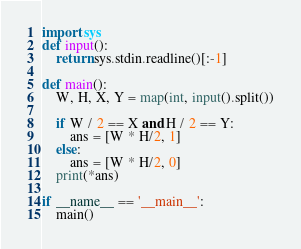Convert code to text. <code><loc_0><loc_0><loc_500><loc_500><_Python_>import sys
def input():
    return sys.stdin.readline()[:-1]

def main():
    W, H, X, Y = map(int, input().split())

    if W / 2 == X and H / 2 == Y:
        ans = [W * H/2, 1]
    else:
        ans = [W * H/2, 0]
    print(*ans)

if __name__ == '__main__':
    main()
</code> 